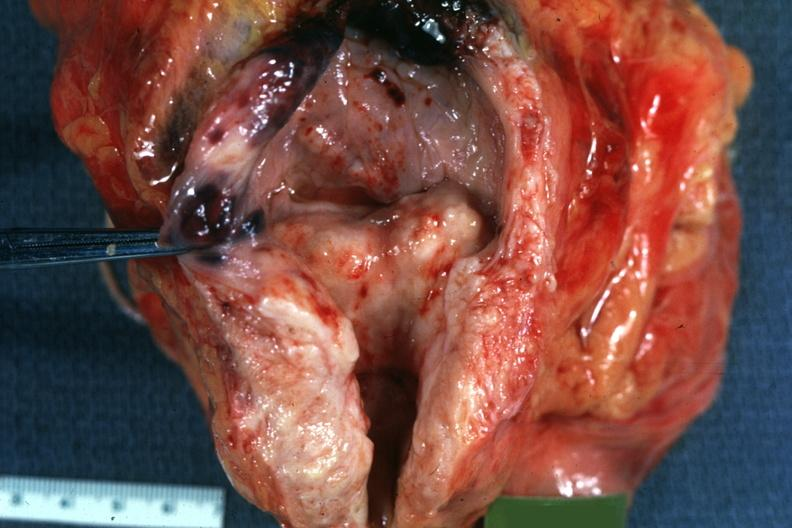s prostate present?
Answer the question using a single word or phrase. Yes 